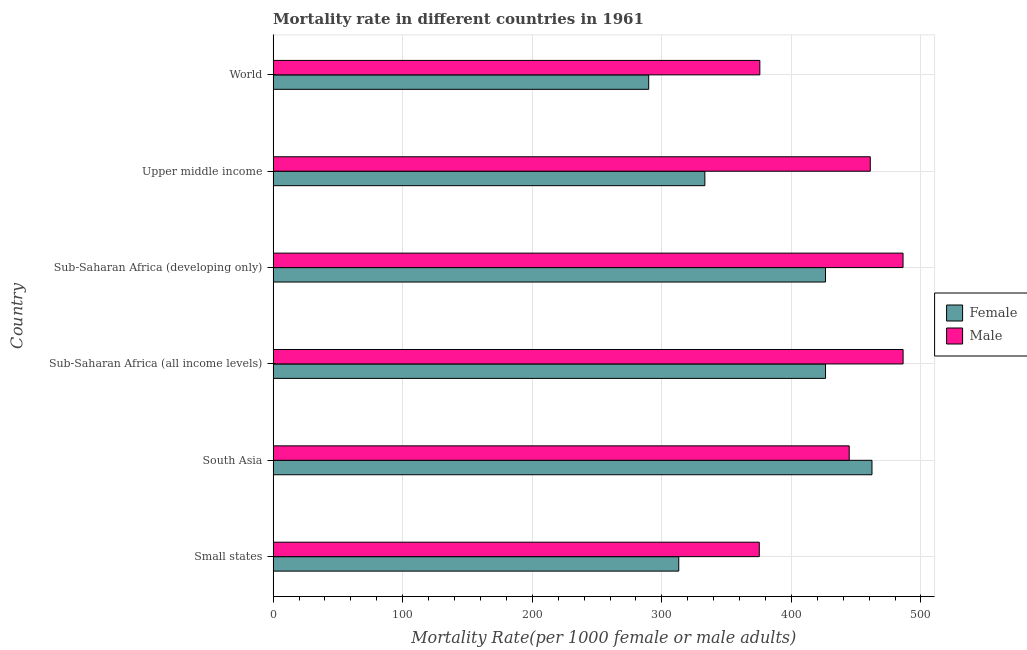How many groups of bars are there?
Provide a succinct answer. 6. Are the number of bars per tick equal to the number of legend labels?
Give a very brief answer. Yes. Are the number of bars on each tick of the Y-axis equal?
Your answer should be very brief. Yes. How many bars are there on the 5th tick from the bottom?
Your answer should be very brief. 2. What is the label of the 2nd group of bars from the top?
Provide a short and direct response. Upper middle income. What is the female mortality rate in Upper middle income?
Ensure brevity in your answer.  333.2. Across all countries, what is the maximum female mortality rate?
Ensure brevity in your answer.  462.19. Across all countries, what is the minimum female mortality rate?
Provide a succinct answer. 289.86. In which country was the male mortality rate maximum?
Make the answer very short. Sub-Saharan Africa (all income levels). What is the total female mortality rate in the graph?
Offer a very short reply. 2250.93. What is the difference between the female mortality rate in Upper middle income and that in World?
Your response must be concise. 43.34. What is the difference between the male mortality rate in World and the female mortality rate in Sub-Saharan Africa (all income levels)?
Offer a terse response. -50.69. What is the average male mortality rate per country?
Ensure brevity in your answer.  438.11. What is the difference between the male mortality rate and female mortality rate in Small states?
Offer a terse response. 62.15. What is the ratio of the male mortality rate in Sub-Saharan Africa (developing only) to that in World?
Ensure brevity in your answer.  1.29. What is the difference between the highest and the second highest male mortality rate?
Keep it short and to the point. 0.04. What is the difference between the highest and the lowest female mortality rate?
Offer a very short reply. 172.32. How many bars are there?
Keep it short and to the point. 12. Are all the bars in the graph horizontal?
Ensure brevity in your answer.  Yes. Are the values on the major ticks of X-axis written in scientific E-notation?
Your answer should be compact. No. How many legend labels are there?
Your answer should be very brief. 2. What is the title of the graph?
Give a very brief answer. Mortality rate in different countries in 1961. What is the label or title of the X-axis?
Your response must be concise. Mortality Rate(per 1000 female or male adults). What is the Mortality Rate(per 1000 female or male adults) of Female in Small states?
Your answer should be compact. 313.06. What is the Mortality Rate(per 1000 female or male adults) of Male in Small states?
Keep it short and to the point. 375.21. What is the Mortality Rate(per 1000 female or male adults) in Female in South Asia?
Give a very brief answer. 462.19. What is the Mortality Rate(per 1000 female or male adults) of Male in South Asia?
Provide a short and direct response. 444.61. What is the Mortality Rate(per 1000 female or male adults) of Female in Sub-Saharan Africa (all income levels)?
Offer a very short reply. 426.33. What is the Mortality Rate(per 1000 female or male adults) of Male in Sub-Saharan Africa (all income levels)?
Your response must be concise. 486.19. What is the Mortality Rate(per 1000 female or male adults) in Female in Sub-Saharan Africa (developing only)?
Your answer should be compact. 426.29. What is the Mortality Rate(per 1000 female or male adults) of Male in Sub-Saharan Africa (developing only)?
Your response must be concise. 486.15. What is the Mortality Rate(per 1000 female or male adults) of Female in Upper middle income?
Keep it short and to the point. 333.2. What is the Mortality Rate(per 1000 female or male adults) in Male in Upper middle income?
Offer a terse response. 460.87. What is the Mortality Rate(per 1000 female or male adults) in Female in World?
Your answer should be very brief. 289.86. What is the Mortality Rate(per 1000 female or male adults) of Male in World?
Make the answer very short. 375.63. Across all countries, what is the maximum Mortality Rate(per 1000 female or male adults) of Female?
Provide a short and direct response. 462.19. Across all countries, what is the maximum Mortality Rate(per 1000 female or male adults) in Male?
Provide a succinct answer. 486.19. Across all countries, what is the minimum Mortality Rate(per 1000 female or male adults) of Female?
Keep it short and to the point. 289.86. Across all countries, what is the minimum Mortality Rate(per 1000 female or male adults) in Male?
Give a very brief answer. 375.21. What is the total Mortality Rate(per 1000 female or male adults) of Female in the graph?
Your answer should be compact. 2250.93. What is the total Mortality Rate(per 1000 female or male adults) in Male in the graph?
Provide a short and direct response. 2628.66. What is the difference between the Mortality Rate(per 1000 female or male adults) of Female in Small states and that in South Asia?
Make the answer very short. -149.12. What is the difference between the Mortality Rate(per 1000 female or male adults) of Male in Small states and that in South Asia?
Your answer should be compact. -69.4. What is the difference between the Mortality Rate(per 1000 female or male adults) in Female in Small states and that in Sub-Saharan Africa (all income levels)?
Provide a succinct answer. -113.27. What is the difference between the Mortality Rate(per 1000 female or male adults) in Male in Small states and that in Sub-Saharan Africa (all income levels)?
Offer a terse response. -110.98. What is the difference between the Mortality Rate(per 1000 female or male adults) in Female in Small states and that in Sub-Saharan Africa (developing only)?
Ensure brevity in your answer.  -113.23. What is the difference between the Mortality Rate(per 1000 female or male adults) in Male in Small states and that in Sub-Saharan Africa (developing only)?
Make the answer very short. -110.94. What is the difference between the Mortality Rate(per 1000 female or male adults) in Female in Small states and that in Upper middle income?
Your answer should be very brief. -20.14. What is the difference between the Mortality Rate(per 1000 female or male adults) in Male in Small states and that in Upper middle income?
Your response must be concise. -85.66. What is the difference between the Mortality Rate(per 1000 female or male adults) in Female in Small states and that in World?
Provide a succinct answer. 23.2. What is the difference between the Mortality Rate(per 1000 female or male adults) of Male in Small states and that in World?
Your answer should be compact. -0.43. What is the difference between the Mortality Rate(per 1000 female or male adults) in Female in South Asia and that in Sub-Saharan Africa (all income levels)?
Make the answer very short. 35.86. What is the difference between the Mortality Rate(per 1000 female or male adults) of Male in South Asia and that in Sub-Saharan Africa (all income levels)?
Ensure brevity in your answer.  -41.57. What is the difference between the Mortality Rate(per 1000 female or male adults) in Female in South Asia and that in Sub-Saharan Africa (developing only)?
Make the answer very short. 35.89. What is the difference between the Mortality Rate(per 1000 female or male adults) of Male in South Asia and that in Sub-Saharan Africa (developing only)?
Your response must be concise. -41.54. What is the difference between the Mortality Rate(per 1000 female or male adults) in Female in South Asia and that in Upper middle income?
Offer a very short reply. 128.98. What is the difference between the Mortality Rate(per 1000 female or male adults) in Male in South Asia and that in Upper middle income?
Offer a terse response. -16.26. What is the difference between the Mortality Rate(per 1000 female or male adults) of Female in South Asia and that in World?
Offer a very short reply. 172.32. What is the difference between the Mortality Rate(per 1000 female or male adults) in Male in South Asia and that in World?
Keep it short and to the point. 68.98. What is the difference between the Mortality Rate(per 1000 female or male adults) of Female in Sub-Saharan Africa (all income levels) and that in Sub-Saharan Africa (developing only)?
Offer a terse response. 0.03. What is the difference between the Mortality Rate(per 1000 female or male adults) of Male in Sub-Saharan Africa (all income levels) and that in Sub-Saharan Africa (developing only)?
Your answer should be compact. 0.04. What is the difference between the Mortality Rate(per 1000 female or male adults) of Female in Sub-Saharan Africa (all income levels) and that in Upper middle income?
Offer a very short reply. 93.12. What is the difference between the Mortality Rate(per 1000 female or male adults) of Male in Sub-Saharan Africa (all income levels) and that in Upper middle income?
Ensure brevity in your answer.  25.32. What is the difference between the Mortality Rate(per 1000 female or male adults) of Female in Sub-Saharan Africa (all income levels) and that in World?
Ensure brevity in your answer.  136.47. What is the difference between the Mortality Rate(per 1000 female or male adults) of Male in Sub-Saharan Africa (all income levels) and that in World?
Give a very brief answer. 110.55. What is the difference between the Mortality Rate(per 1000 female or male adults) of Female in Sub-Saharan Africa (developing only) and that in Upper middle income?
Your response must be concise. 93.09. What is the difference between the Mortality Rate(per 1000 female or male adults) in Male in Sub-Saharan Africa (developing only) and that in Upper middle income?
Offer a very short reply. 25.28. What is the difference between the Mortality Rate(per 1000 female or male adults) of Female in Sub-Saharan Africa (developing only) and that in World?
Give a very brief answer. 136.43. What is the difference between the Mortality Rate(per 1000 female or male adults) in Male in Sub-Saharan Africa (developing only) and that in World?
Provide a succinct answer. 110.52. What is the difference between the Mortality Rate(per 1000 female or male adults) of Female in Upper middle income and that in World?
Your response must be concise. 43.34. What is the difference between the Mortality Rate(per 1000 female or male adults) in Male in Upper middle income and that in World?
Your answer should be compact. 85.24. What is the difference between the Mortality Rate(per 1000 female or male adults) of Female in Small states and the Mortality Rate(per 1000 female or male adults) of Male in South Asia?
Ensure brevity in your answer.  -131.55. What is the difference between the Mortality Rate(per 1000 female or male adults) of Female in Small states and the Mortality Rate(per 1000 female or male adults) of Male in Sub-Saharan Africa (all income levels)?
Ensure brevity in your answer.  -173.13. What is the difference between the Mortality Rate(per 1000 female or male adults) in Female in Small states and the Mortality Rate(per 1000 female or male adults) in Male in Sub-Saharan Africa (developing only)?
Provide a succinct answer. -173.09. What is the difference between the Mortality Rate(per 1000 female or male adults) of Female in Small states and the Mortality Rate(per 1000 female or male adults) of Male in Upper middle income?
Give a very brief answer. -147.81. What is the difference between the Mortality Rate(per 1000 female or male adults) of Female in Small states and the Mortality Rate(per 1000 female or male adults) of Male in World?
Ensure brevity in your answer.  -62.57. What is the difference between the Mortality Rate(per 1000 female or male adults) of Female in South Asia and the Mortality Rate(per 1000 female or male adults) of Male in Sub-Saharan Africa (all income levels)?
Provide a succinct answer. -24. What is the difference between the Mortality Rate(per 1000 female or male adults) in Female in South Asia and the Mortality Rate(per 1000 female or male adults) in Male in Sub-Saharan Africa (developing only)?
Make the answer very short. -23.96. What is the difference between the Mortality Rate(per 1000 female or male adults) of Female in South Asia and the Mortality Rate(per 1000 female or male adults) of Male in Upper middle income?
Keep it short and to the point. 1.31. What is the difference between the Mortality Rate(per 1000 female or male adults) in Female in South Asia and the Mortality Rate(per 1000 female or male adults) in Male in World?
Keep it short and to the point. 86.55. What is the difference between the Mortality Rate(per 1000 female or male adults) in Female in Sub-Saharan Africa (all income levels) and the Mortality Rate(per 1000 female or male adults) in Male in Sub-Saharan Africa (developing only)?
Provide a succinct answer. -59.82. What is the difference between the Mortality Rate(per 1000 female or male adults) in Female in Sub-Saharan Africa (all income levels) and the Mortality Rate(per 1000 female or male adults) in Male in Upper middle income?
Provide a short and direct response. -34.54. What is the difference between the Mortality Rate(per 1000 female or male adults) in Female in Sub-Saharan Africa (all income levels) and the Mortality Rate(per 1000 female or male adults) in Male in World?
Give a very brief answer. 50.69. What is the difference between the Mortality Rate(per 1000 female or male adults) in Female in Sub-Saharan Africa (developing only) and the Mortality Rate(per 1000 female or male adults) in Male in Upper middle income?
Give a very brief answer. -34.58. What is the difference between the Mortality Rate(per 1000 female or male adults) of Female in Sub-Saharan Africa (developing only) and the Mortality Rate(per 1000 female or male adults) of Male in World?
Your response must be concise. 50.66. What is the difference between the Mortality Rate(per 1000 female or male adults) of Female in Upper middle income and the Mortality Rate(per 1000 female or male adults) of Male in World?
Ensure brevity in your answer.  -42.43. What is the average Mortality Rate(per 1000 female or male adults) of Female per country?
Provide a succinct answer. 375.16. What is the average Mortality Rate(per 1000 female or male adults) of Male per country?
Provide a short and direct response. 438.11. What is the difference between the Mortality Rate(per 1000 female or male adults) of Female and Mortality Rate(per 1000 female or male adults) of Male in Small states?
Provide a short and direct response. -62.15. What is the difference between the Mortality Rate(per 1000 female or male adults) of Female and Mortality Rate(per 1000 female or male adults) of Male in South Asia?
Your answer should be compact. 17.57. What is the difference between the Mortality Rate(per 1000 female or male adults) in Female and Mortality Rate(per 1000 female or male adults) in Male in Sub-Saharan Africa (all income levels)?
Give a very brief answer. -59.86. What is the difference between the Mortality Rate(per 1000 female or male adults) in Female and Mortality Rate(per 1000 female or male adults) in Male in Sub-Saharan Africa (developing only)?
Your answer should be very brief. -59.86. What is the difference between the Mortality Rate(per 1000 female or male adults) in Female and Mortality Rate(per 1000 female or male adults) in Male in Upper middle income?
Provide a short and direct response. -127.67. What is the difference between the Mortality Rate(per 1000 female or male adults) of Female and Mortality Rate(per 1000 female or male adults) of Male in World?
Keep it short and to the point. -85.77. What is the ratio of the Mortality Rate(per 1000 female or male adults) in Female in Small states to that in South Asia?
Offer a very short reply. 0.68. What is the ratio of the Mortality Rate(per 1000 female or male adults) in Male in Small states to that in South Asia?
Provide a succinct answer. 0.84. What is the ratio of the Mortality Rate(per 1000 female or male adults) in Female in Small states to that in Sub-Saharan Africa (all income levels)?
Give a very brief answer. 0.73. What is the ratio of the Mortality Rate(per 1000 female or male adults) in Male in Small states to that in Sub-Saharan Africa (all income levels)?
Make the answer very short. 0.77. What is the ratio of the Mortality Rate(per 1000 female or male adults) of Female in Small states to that in Sub-Saharan Africa (developing only)?
Your answer should be compact. 0.73. What is the ratio of the Mortality Rate(per 1000 female or male adults) in Male in Small states to that in Sub-Saharan Africa (developing only)?
Your answer should be compact. 0.77. What is the ratio of the Mortality Rate(per 1000 female or male adults) in Female in Small states to that in Upper middle income?
Your answer should be very brief. 0.94. What is the ratio of the Mortality Rate(per 1000 female or male adults) in Male in Small states to that in Upper middle income?
Provide a succinct answer. 0.81. What is the ratio of the Mortality Rate(per 1000 female or male adults) of Female in Small states to that in World?
Ensure brevity in your answer.  1.08. What is the ratio of the Mortality Rate(per 1000 female or male adults) of Male in Small states to that in World?
Make the answer very short. 1. What is the ratio of the Mortality Rate(per 1000 female or male adults) in Female in South Asia to that in Sub-Saharan Africa (all income levels)?
Your answer should be very brief. 1.08. What is the ratio of the Mortality Rate(per 1000 female or male adults) in Male in South Asia to that in Sub-Saharan Africa (all income levels)?
Make the answer very short. 0.91. What is the ratio of the Mortality Rate(per 1000 female or male adults) in Female in South Asia to that in Sub-Saharan Africa (developing only)?
Ensure brevity in your answer.  1.08. What is the ratio of the Mortality Rate(per 1000 female or male adults) in Male in South Asia to that in Sub-Saharan Africa (developing only)?
Keep it short and to the point. 0.91. What is the ratio of the Mortality Rate(per 1000 female or male adults) in Female in South Asia to that in Upper middle income?
Provide a short and direct response. 1.39. What is the ratio of the Mortality Rate(per 1000 female or male adults) of Male in South Asia to that in Upper middle income?
Keep it short and to the point. 0.96. What is the ratio of the Mortality Rate(per 1000 female or male adults) in Female in South Asia to that in World?
Keep it short and to the point. 1.59. What is the ratio of the Mortality Rate(per 1000 female or male adults) of Male in South Asia to that in World?
Make the answer very short. 1.18. What is the ratio of the Mortality Rate(per 1000 female or male adults) in Male in Sub-Saharan Africa (all income levels) to that in Sub-Saharan Africa (developing only)?
Ensure brevity in your answer.  1. What is the ratio of the Mortality Rate(per 1000 female or male adults) in Female in Sub-Saharan Africa (all income levels) to that in Upper middle income?
Your answer should be compact. 1.28. What is the ratio of the Mortality Rate(per 1000 female or male adults) in Male in Sub-Saharan Africa (all income levels) to that in Upper middle income?
Give a very brief answer. 1.05. What is the ratio of the Mortality Rate(per 1000 female or male adults) of Female in Sub-Saharan Africa (all income levels) to that in World?
Offer a terse response. 1.47. What is the ratio of the Mortality Rate(per 1000 female or male adults) in Male in Sub-Saharan Africa (all income levels) to that in World?
Offer a very short reply. 1.29. What is the ratio of the Mortality Rate(per 1000 female or male adults) in Female in Sub-Saharan Africa (developing only) to that in Upper middle income?
Ensure brevity in your answer.  1.28. What is the ratio of the Mortality Rate(per 1000 female or male adults) of Male in Sub-Saharan Africa (developing only) to that in Upper middle income?
Your answer should be compact. 1.05. What is the ratio of the Mortality Rate(per 1000 female or male adults) of Female in Sub-Saharan Africa (developing only) to that in World?
Your answer should be compact. 1.47. What is the ratio of the Mortality Rate(per 1000 female or male adults) in Male in Sub-Saharan Africa (developing only) to that in World?
Your response must be concise. 1.29. What is the ratio of the Mortality Rate(per 1000 female or male adults) in Female in Upper middle income to that in World?
Give a very brief answer. 1.15. What is the ratio of the Mortality Rate(per 1000 female or male adults) in Male in Upper middle income to that in World?
Ensure brevity in your answer.  1.23. What is the difference between the highest and the second highest Mortality Rate(per 1000 female or male adults) of Female?
Provide a short and direct response. 35.86. What is the difference between the highest and the second highest Mortality Rate(per 1000 female or male adults) in Male?
Your response must be concise. 0.04. What is the difference between the highest and the lowest Mortality Rate(per 1000 female or male adults) in Female?
Offer a very short reply. 172.32. What is the difference between the highest and the lowest Mortality Rate(per 1000 female or male adults) in Male?
Keep it short and to the point. 110.98. 